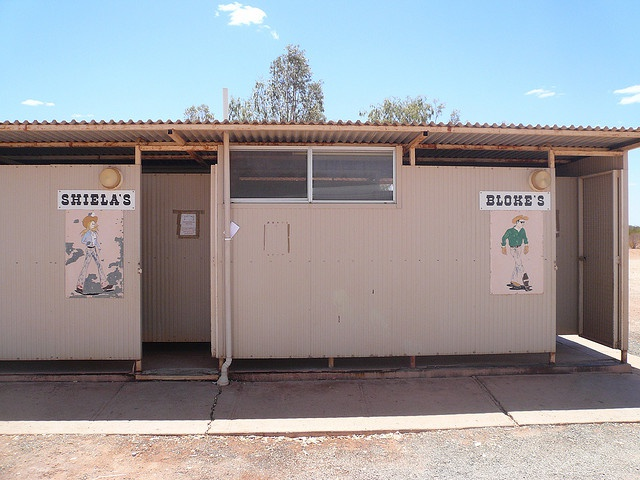Describe the objects in this image and their specific colors. I can see various objects in this image with different colors. 